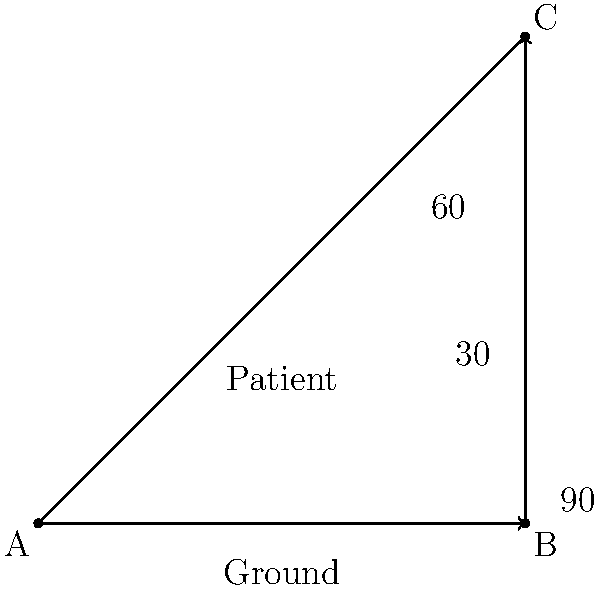During CPR, the patient's upper body needs to be elevated at a specific angle for optimal chest compressions. Based on the diagram, which angle provides the correct patient positioning for effective CPR? To determine the correct angle for patient positioning during CPR, let's follow these steps:

1. In the diagram, we see a right-angled triangle representing the patient's position relative to the ground.

2. The right angle ($90°$) represents the vertical position, which is not suitable for CPR as it would place the patient completely upright.

3. We are presented with two other angles: $30°$ and $60°$.

4. According to current CPR guidelines, the patient's upper body should be elevated at approximately $30°$ for optimal chest compressions. This slight elevation helps to:
   a) Improve blood flow to the heart and brain
   b) Reduce the risk of aspiration
   c) Facilitate easier and more effective chest compressions

5. The $60°$ angle would place the patient in a more upright position, which is not ideal for CPR as it would make chest compressions less effective and potentially cause the patient to slide.

6. Therefore, the $30°$ angle provides the correct patient positioning for effective CPR.
Answer: $30°$ 